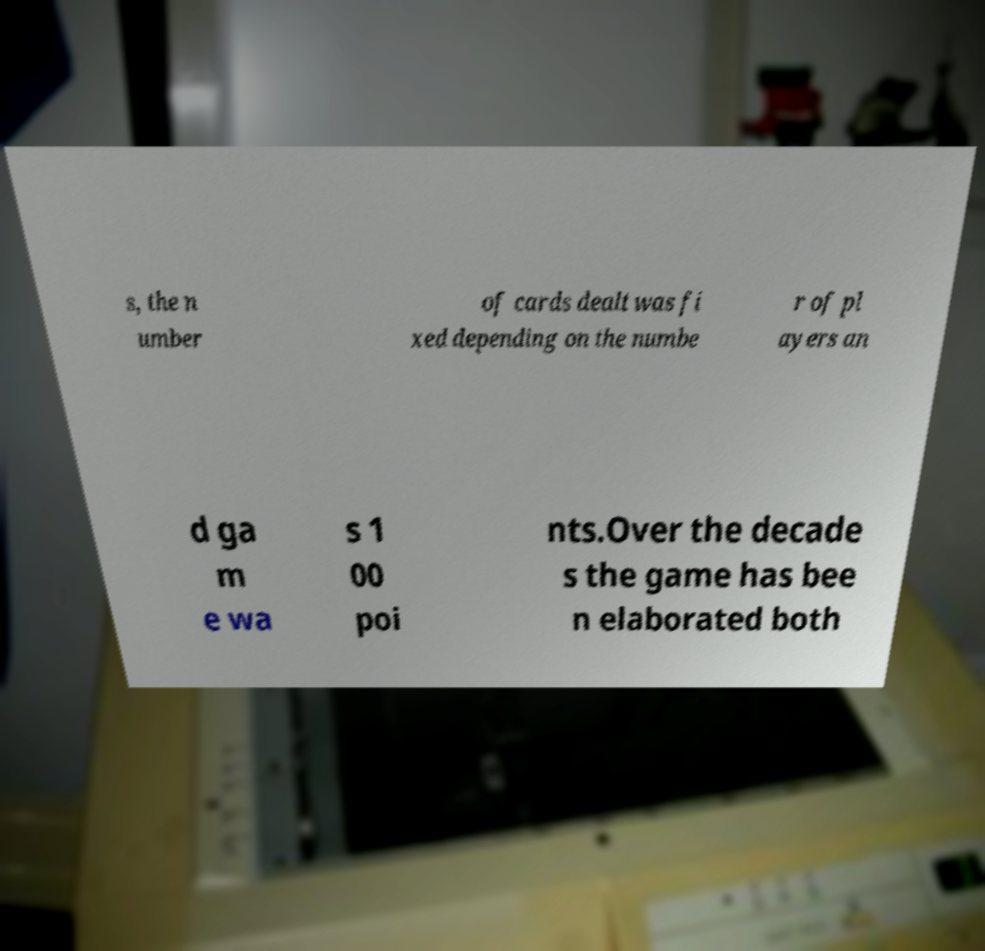What messages or text are displayed in this image? I need them in a readable, typed format. s, the n umber of cards dealt was fi xed depending on the numbe r of pl ayers an d ga m e wa s 1 00 poi nts.Over the decade s the game has bee n elaborated both 